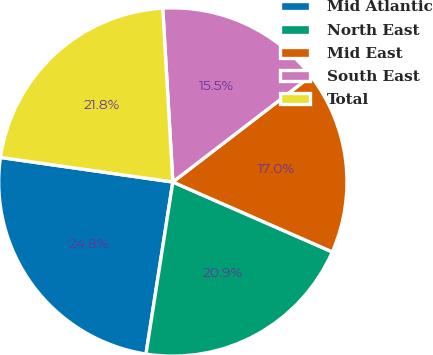<chart> <loc_0><loc_0><loc_500><loc_500><pie_chart><fcel>Mid Atlantic<fcel>North East<fcel>Mid East<fcel>South East<fcel>Total<nl><fcel>24.79%<fcel>20.89%<fcel>16.99%<fcel>15.51%<fcel>21.82%<nl></chart> 